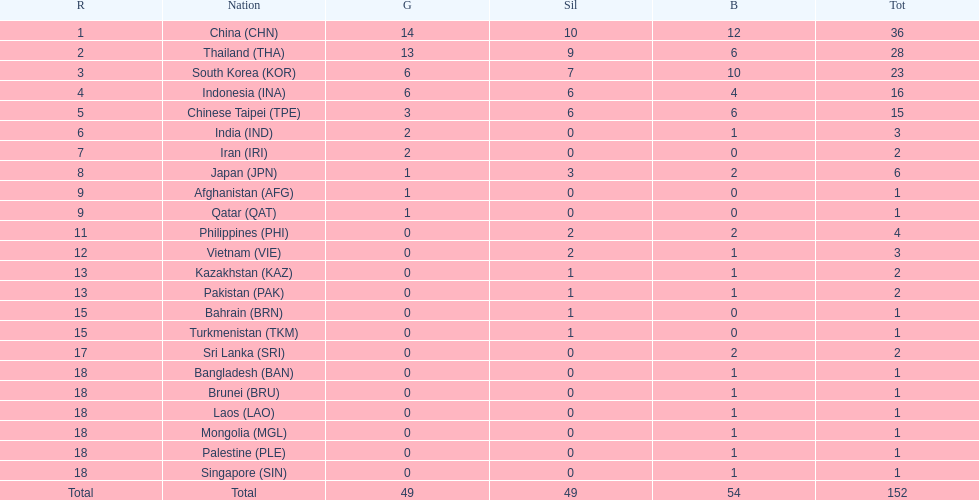How many combined silver medals did china, india, and japan earn ? 13. 